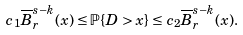<formula> <loc_0><loc_0><loc_500><loc_500>c _ { 1 } \overline { B } _ { r } ^ { s - k } ( x ) \leq { \mathbb { P } } \{ D > x \} \leq c _ { 2 } \overline { B } _ { r } ^ { s - k } ( x ) .</formula> 